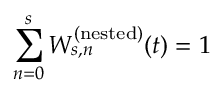<formula> <loc_0><loc_0><loc_500><loc_500>\sum _ { n = 0 } ^ { s } W _ { s , n } ^ { ( n e s t e d ) } ( t ) = 1</formula> 